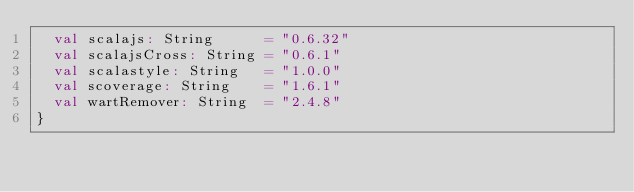Convert code to text. <code><loc_0><loc_0><loc_500><loc_500><_Scala_>  val scalajs: String      = "0.6.32"
  val scalajsCross: String = "0.6.1"
  val scalastyle: String   = "1.0.0"
  val scoverage: String    = "1.6.1"
  val wartRemover: String  = "2.4.8"
}
</code> 